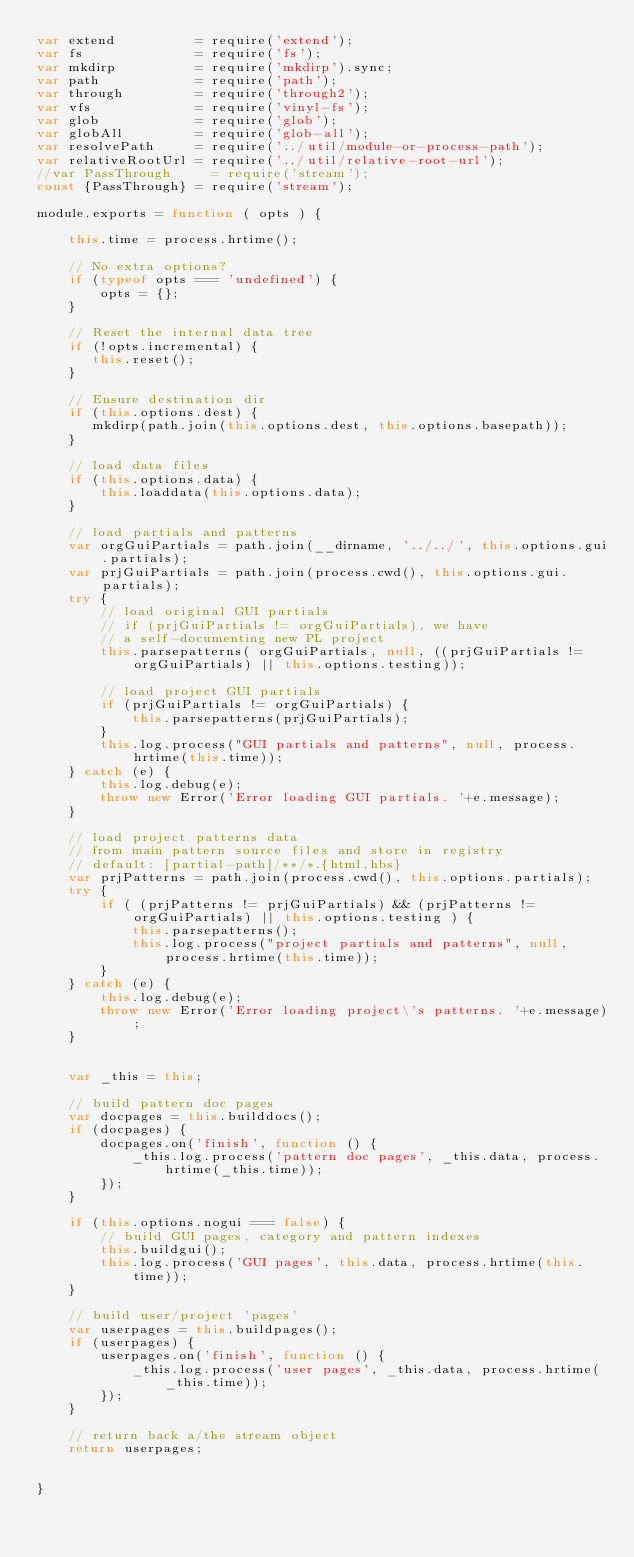<code> <loc_0><loc_0><loc_500><loc_500><_JavaScript_>var extend          = require('extend');
var fs              = require('fs');
var mkdirp          = require('mkdirp').sync;
var path            = require('path');
var through         = require('through2');
var vfs             = require('vinyl-fs');
var glob            = require('glob');
var globAll         = require('glob-all');
var resolvePath     = require('../util/module-or-process-path');
var relativeRootUrl = require('../util/relative-root-url');
//var PassThrough     = require('stream');
const {PassThrough} = require('stream');

module.exports = function ( opts ) {
    
    this.time = process.hrtime();
    
    // No extra options?
    if (typeof opts === 'undefined') {
        opts = {};
    }

    // Reset the internal data tree
    if (!opts.incremental) {
       this.reset();
    }

    // Ensure destination dir
    if (this.options.dest) {
       mkdirp(path.join(this.options.dest, this.options.basepath));
    }
    
    // load data files
    if (this.options.data) {
        this.loaddata(this.options.data);
    }

    // load partials and patterns
    var orgGuiPartials = path.join(__dirname, '../../', this.options.gui.partials);
    var prjGuiPartials = path.join(process.cwd(), this.options.gui.partials);
    try {
        // load original GUI partials
        // if (prjGuiPartials != orgGuiPartials), we have 
        // a self-documenting new PL project
        this.parsepatterns( orgGuiPartials, null, ((prjGuiPartials != orgGuiPartials) || this.options.testing));
        
        // load project GUI partials
        if (prjGuiPartials != orgGuiPartials) {
            this.parsepatterns(prjGuiPartials);
        }
        this.log.process("GUI partials and patterns", null, process.hrtime(this.time));
    } catch (e) {
        this.log.debug(e);
        throw new Error('Error loading GUI partials. '+e.message);
    }
    
    // load project patterns data
    // from main pattern source files and store in registry
    // default: [partial-path]/**/*.{html,hbs}
    var prjPatterns = path.join(process.cwd(), this.options.partials);
    try {
        if ( (prjPatterns != prjGuiPartials) && (prjPatterns != orgGuiPartials) || this.options.testing ) {
            this.parsepatterns();
            this.log.process("project partials and patterns", null, process.hrtime(this.time));
        }
    } catch (e) {
        this.log.debug(e);
        throw new Error('Error loading project\'s patterns. '+e.message);
    }


    var _this = this;
    
    // build pattern doc pages
    var docpages = this.builddocs();
    if (docpages) {
        docpages.on('finish', function () {
    		_this.log.process('pattern doc pages', _this.data, process.hrtime(_this.time));
    	});
    }

    if (this.options.nogui === false) {
        // build GUI pages, category and pattern indexes
        this.buildgui();
        this.log.process('GUI pages', this.data, process.hrtime(this.time));
    }
    
    // build user/project 'pages'
	var userpages = this.buildpages();
	if (userpages) {
		userpages.on('finish', function () {
			_this.log.process('user pages', _this.data, process.hrtime(_this.time));
		});
	}
	
	// return back a/the stream object
	return userpages;
	
	
}

</code> 